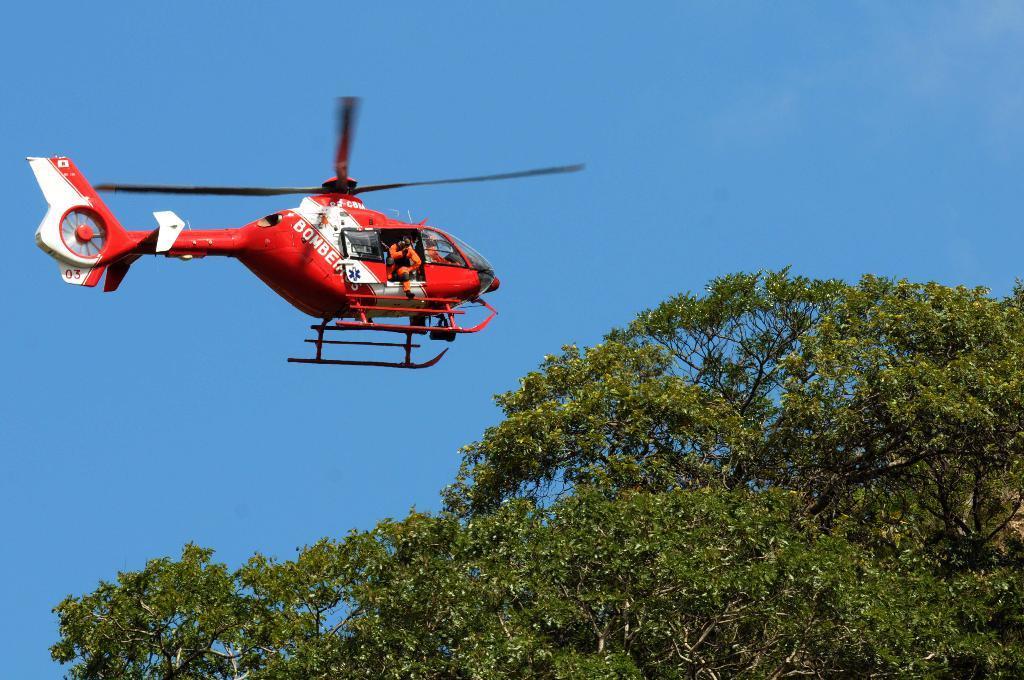How would you summarize this image in a sentence or two? As we can see in the image there is a tree, red color plane and on the top there is a sky. In plane there are few people. 